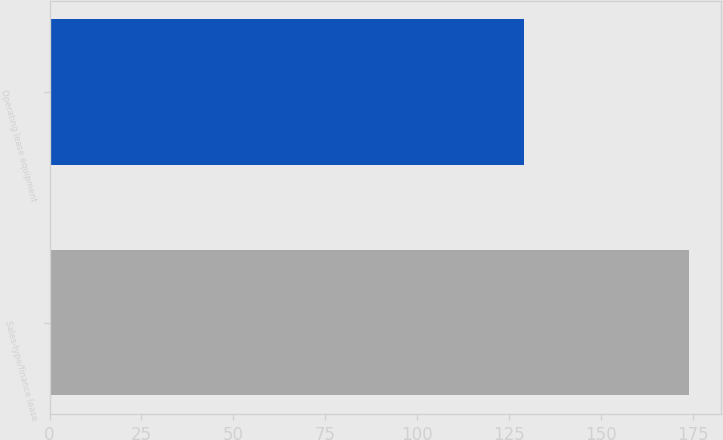Convert chart. <chart><loc_0><loc_0><loc_500><loc_500><bar_chart><fcel>Sales-type/finance lease<fcel>Operating lease equipment<nl><fcel>174<fcel>129<nl></chart> 